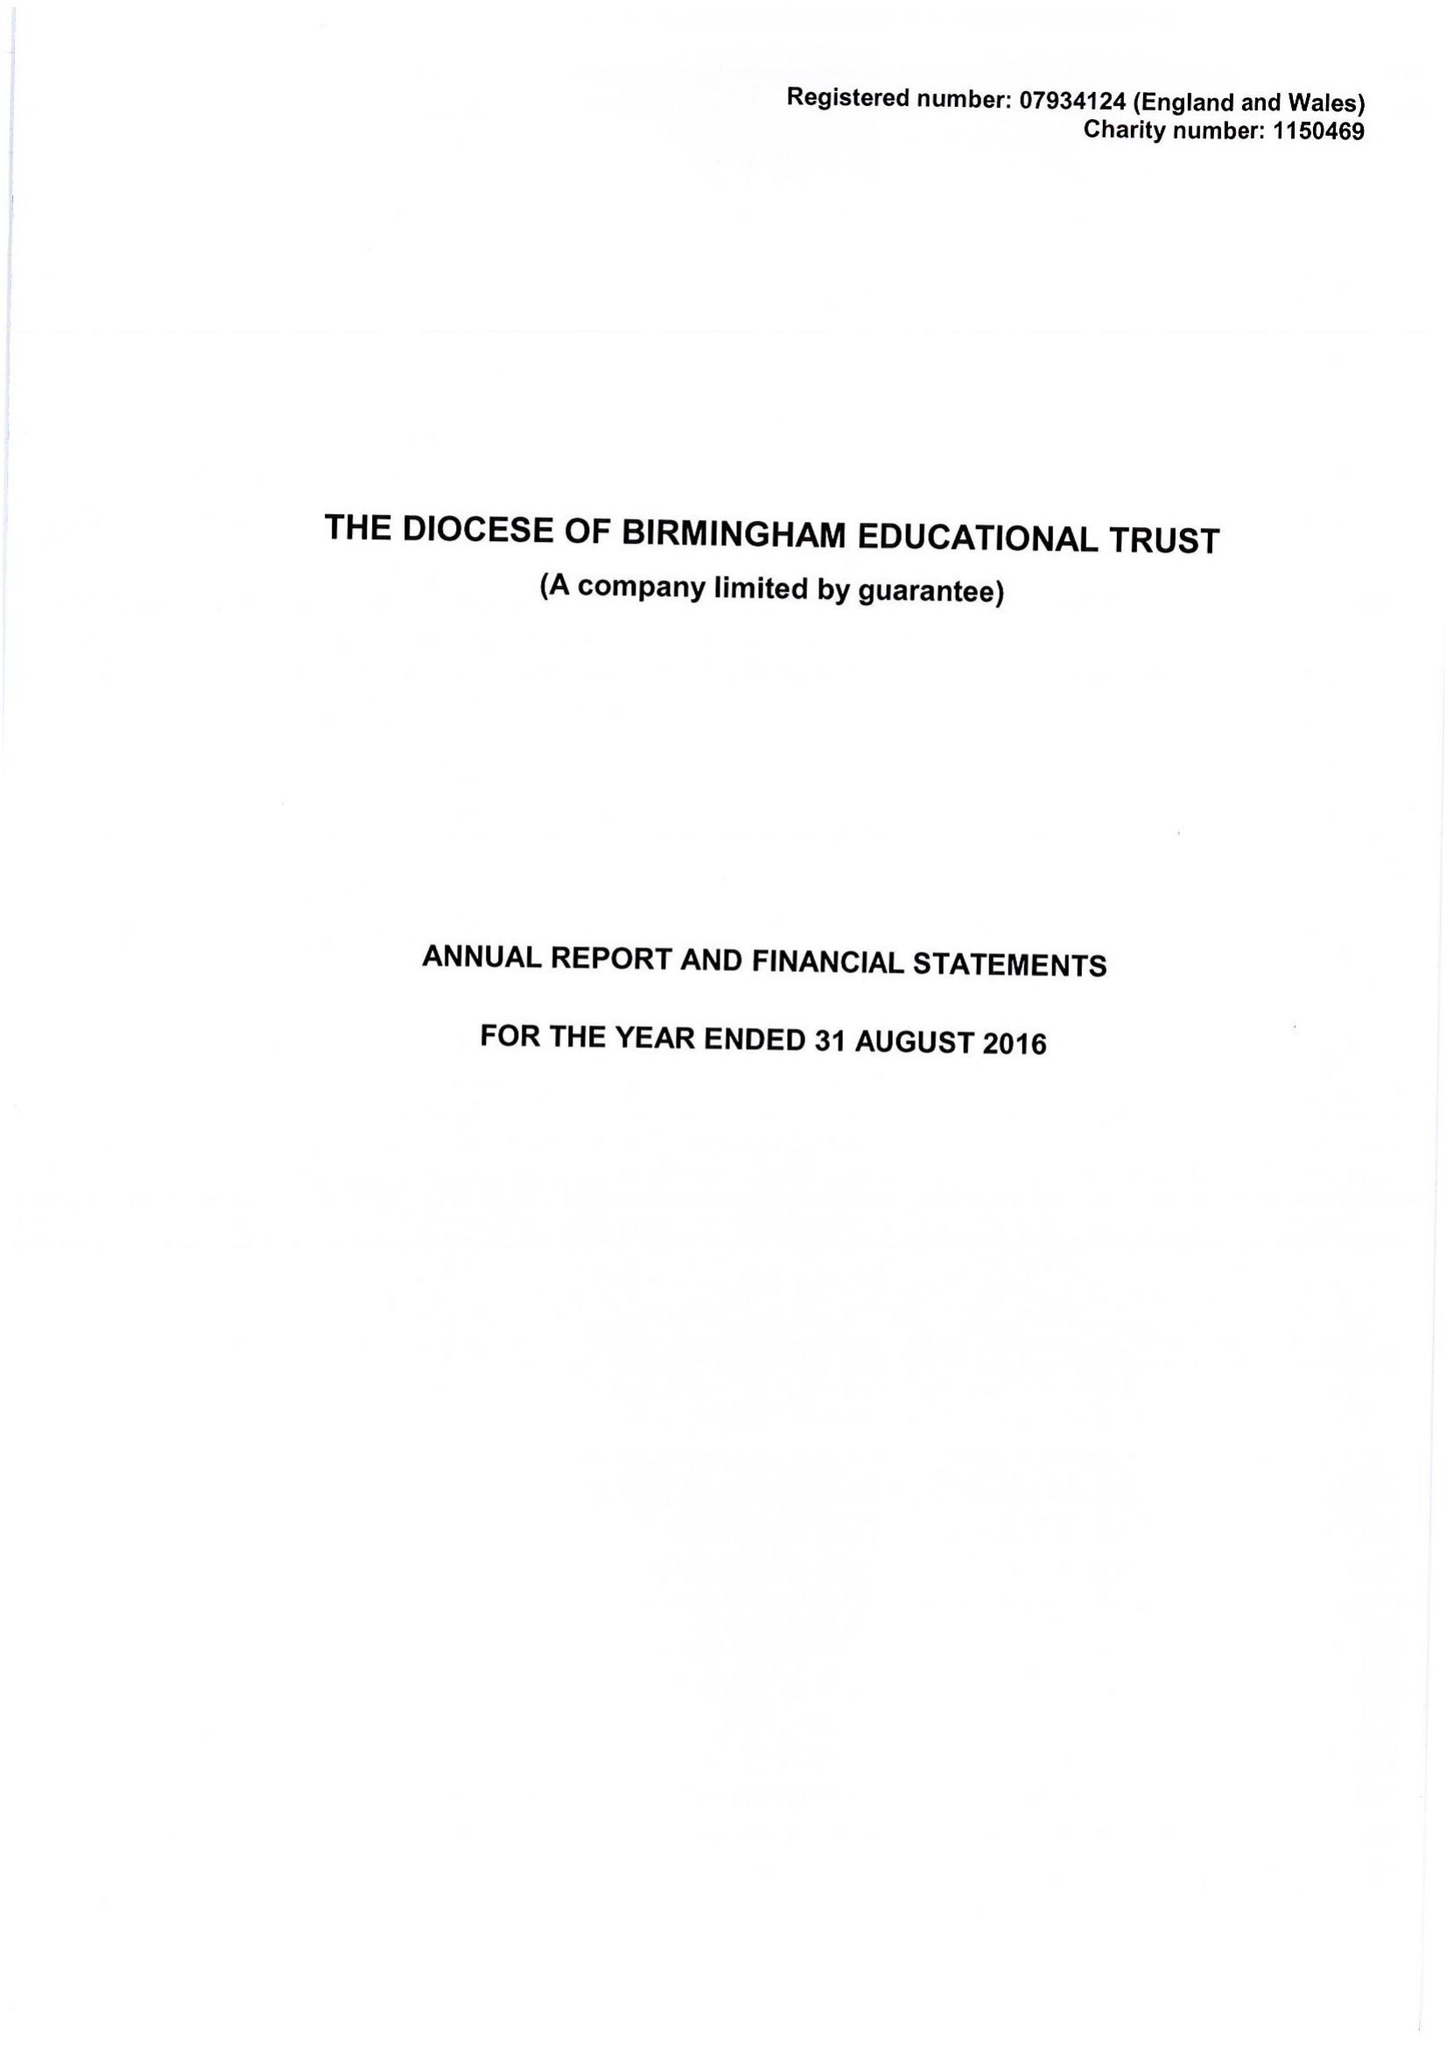What is the value for the charity_name?
Answer the question using a single word or phrase. The Diocese Of Birmingham Educational Trust 